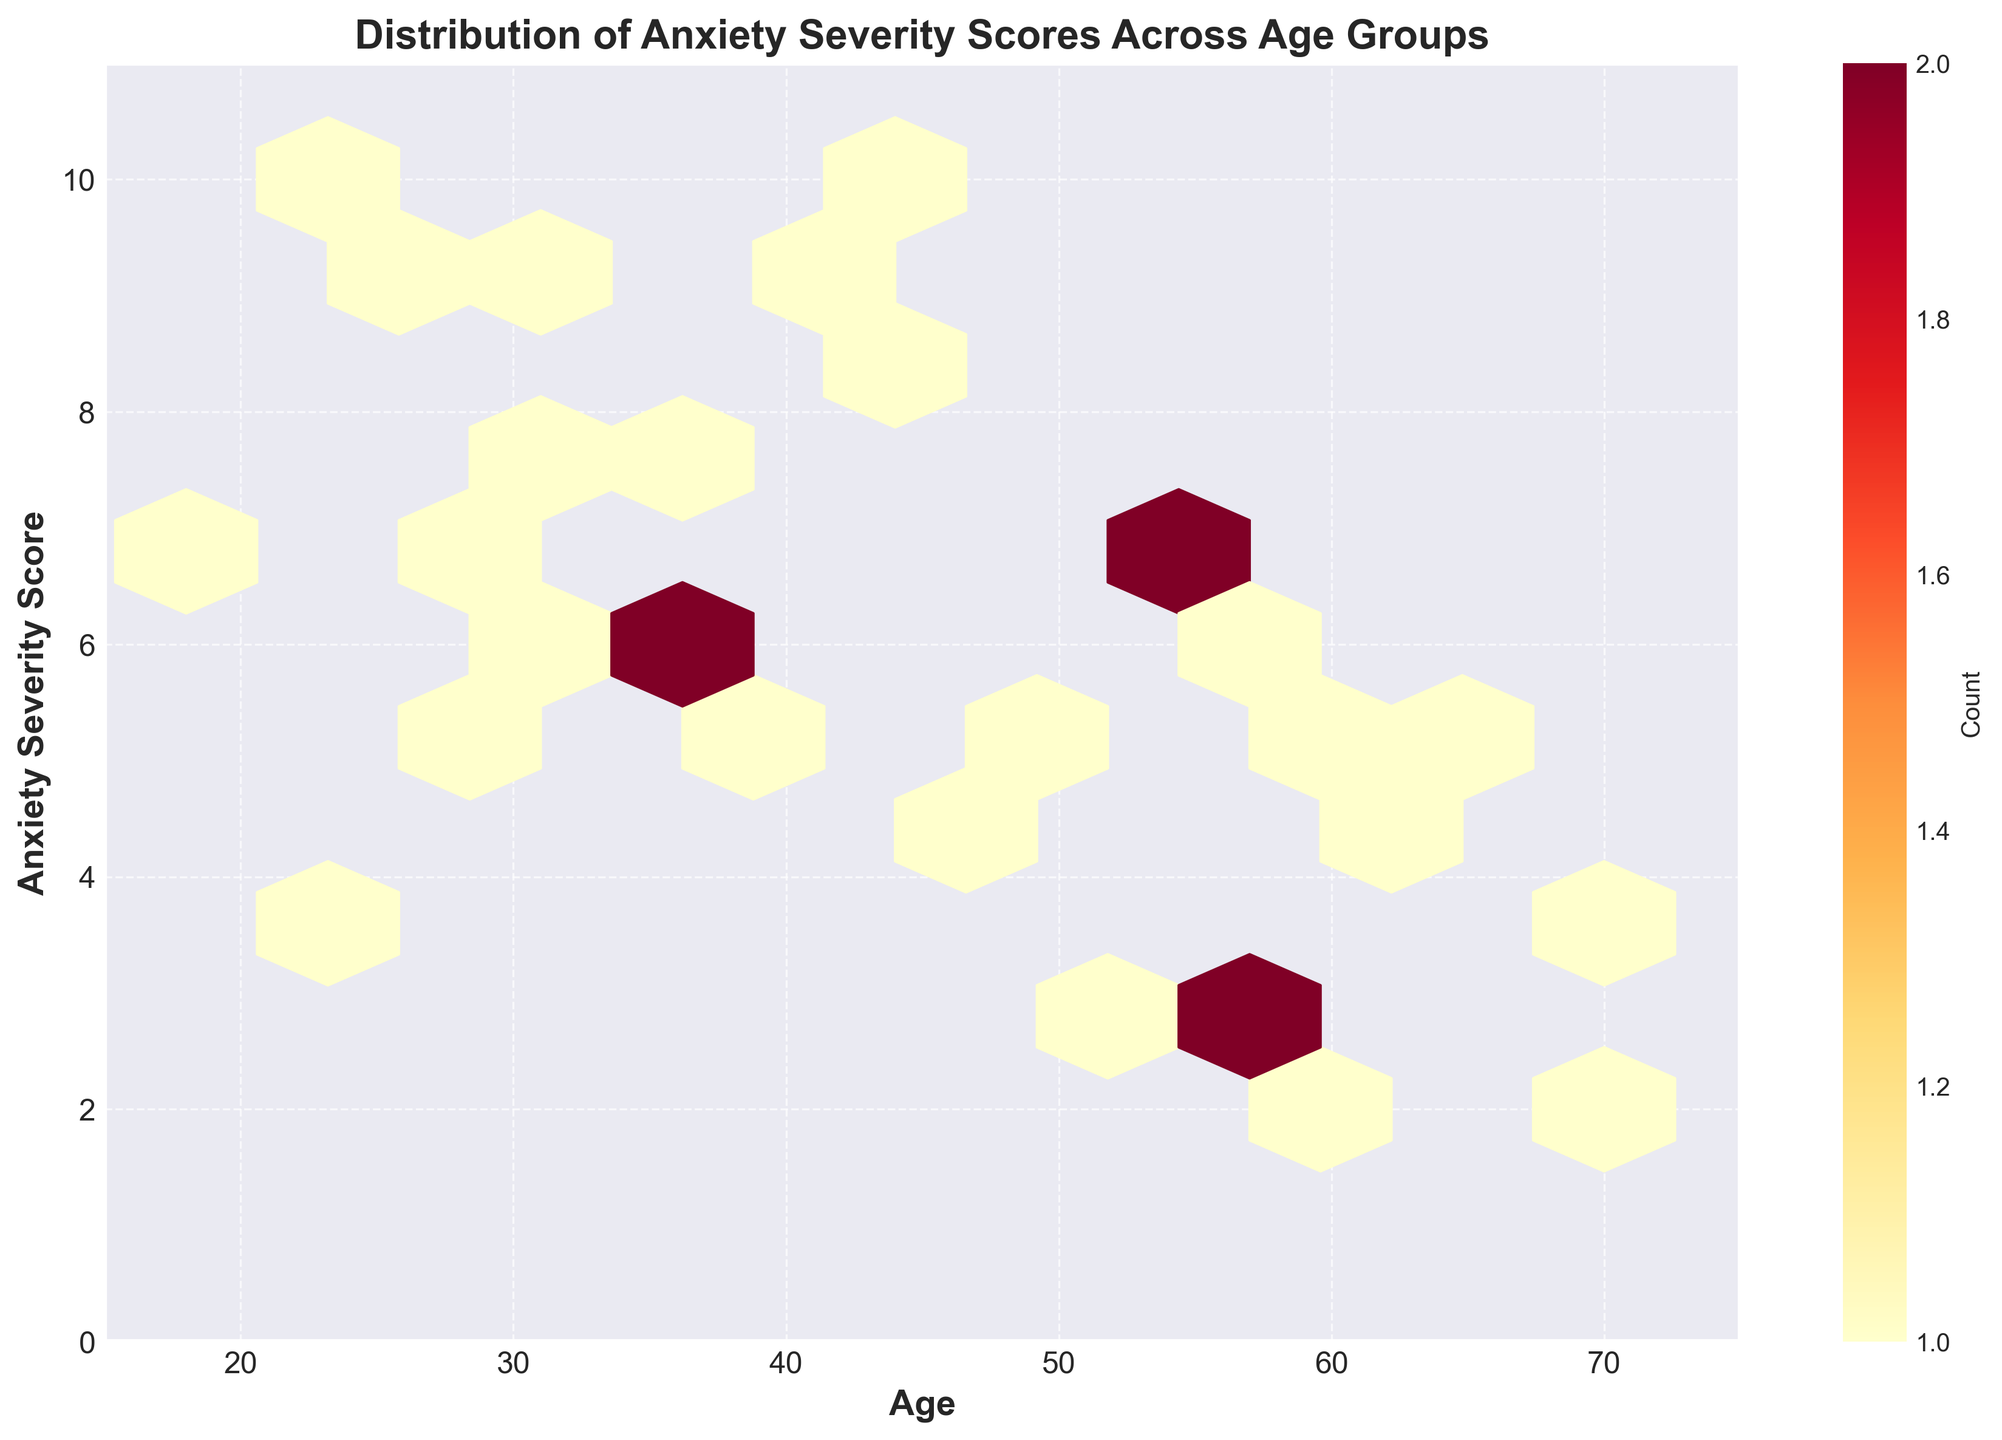what is the title of the figure? The title of the figure is usually displayed at the top and provides a brief description of what the figure represents. In this case, the title is centered at the top in bold text.
Answer: Distribution of Anxiety Severity Scores Across Age Groups What range of ages is covered in the plot? To find the age range, look at the x-axis. The x-axis starts around 15 and ends around 75.
Answer: 15-75 What is the range of anxiety severity scores shown in the plot? The y-axis represents the anxiety severity scores and the values range from the minimum to maximum points on this axis. The y-axis starts at 0 and ends at 11.
Answer: 0-11 How many distinct age groups have anxiety severity scores between 8 and 10? To answer this, look for hexagons on the plot where the y-values are between 8 and 10 and observe the age ranges covered by these hexagons.
Answer: 4 groups (23, 25, 32, 42) What area of the plot has the highest density of data points? The area with the highest density can be found by identifying the hexagons with the warmest colors (reds and oranges) which indicate higher counts.
Answer: Around age 30-40, score 5-7 Which gender categories are compared in this plot? Gender categories are indicated by data points, so you need to refer to the corresponding data records provided. The genders shown are Female, Male, and Non-binary. Natural language term usage is necessary as coding terms might be unfamiliar to some viewers.
Answer: Female, Male, Non-binary What age group most frequently appears with an anxiety severity score of 6? You need to look at the hexagons where the y-axis value is 6 and determine the frequent x-axis values in those hexagons.
Answer: Ages 30, 37, 38 Compare the density of anxiety severity scores for females and males over the age of 50. To compare, observe the different density regions for males and females and count the number of hexagons for ages over 50 that correspond to males and females. Also, pay attention to the color intensity.
Answer: Females seem to have a higher density than males over the age of 50 At what age do we see the highest anxiety severity scores and which gender does it belong to? Check the age value that corresponds with the highest location on the y-axis where the highest severity score is visible and then correlate with gender based on the provided data.
Answer: Age 23, Female 